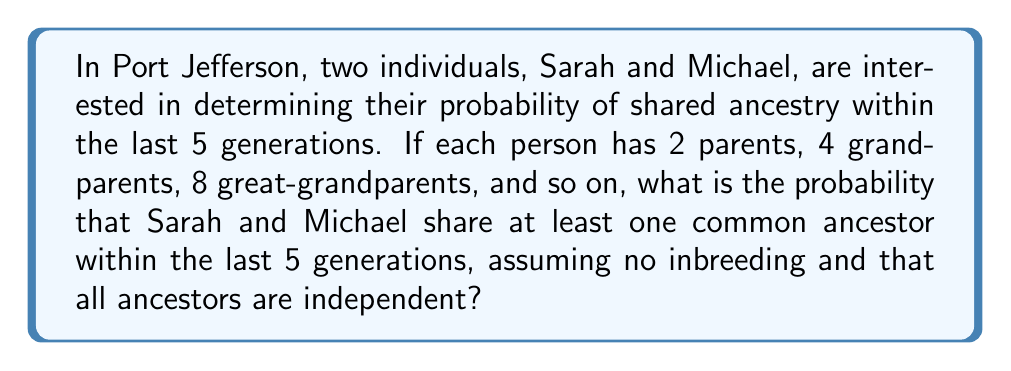Could you help me with this problem? To solve this problem, we need to follow these steps:

1) First, let's calculate the total number of ancestors each person has within 5 generations:
   $$ 2 + 2^2 + 2^3 + 2^4 + 2^5 = 2 + 4 + 8 + 16 + 32 = 62 $$

2) The probability of not sharing an ancestor is the probability that all 62 ancestors of Sarah are different from all 62 ancestors of Michael.

3) Assuming a large population and no inbreeding, we can use the approximation that each ancestor has an independent probability of not being shared.

4) Let's say the population size of Port Jefferson and surrounding areas from which ancestors could come is approximately 100,000.

5) The probability of one specific ancestor of Sarah not being an ancestor of Michael is:
   $$ P(\text{not shared}) = \frac{99999}{100000} = 0.99999 $$

6) For all 62 ancestors to not be shared, this needs to happen 62 times independently:
   $$ P(\text{no shared ancestors}) = (0.99999)^{62} \approx 0.9994 $$

7) Therefore, the probability of sharing at least one ancestor is:
   $$ P(\text{shared ancestor}) = 1 - P(\text{no shared ancestors}) = 1 - 0.9994 = 0.0006 $$
Answer: The probability that Sarah and Michael share at least one common ancestor within the last 5 generations is approximately $0.0006$ or $0.06\%$. 